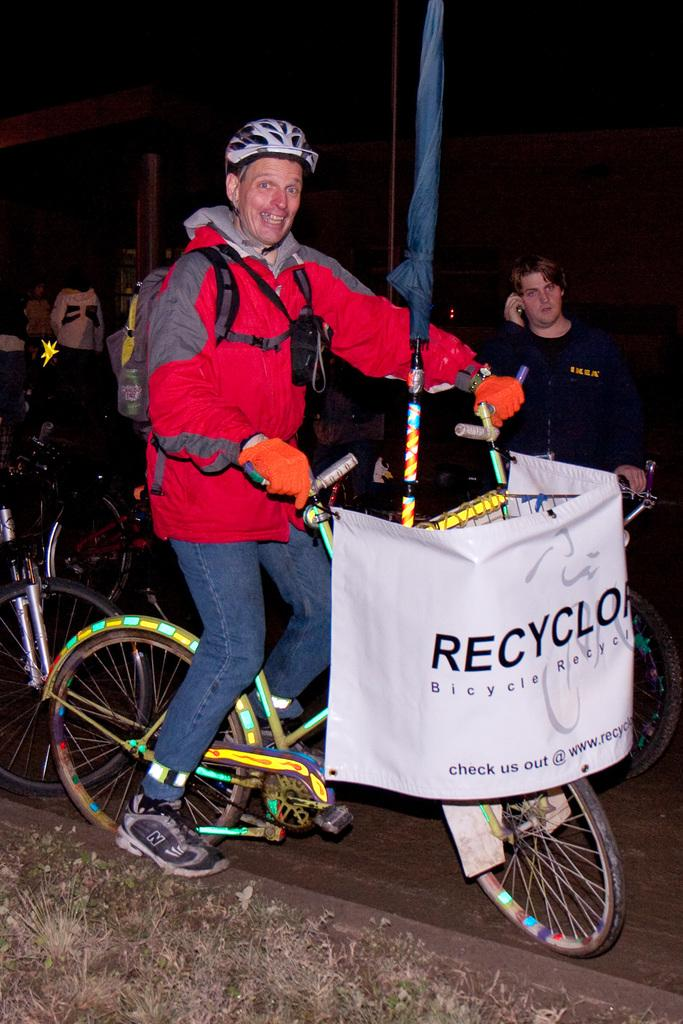What is the person in the image doing? The person is riding a bicycle in the image. What is the person wearing while riding the bicycle? The person is wearing a red jacket. What is attached to the bicycle? There is a white banner attached to the bicycle. What can be seen on the banner? There is text written on the banner. What is visible in the background of the image? There is a group of people in the background of the image. What type of pie is being sold by the person on the bicycle? There is no pie present in the image; the person is riding a bicycle with a white banner attached to it. 